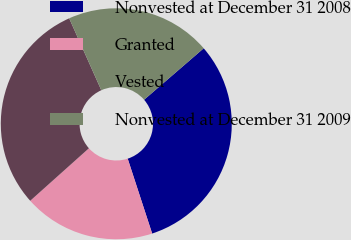Convert chart to OTSL. <chart><loc_0><loc_0><loc_500><loc_500><pie_chart><fcel>Nonvested at December 31 2008<fcel>Granted<fcel>Vested<fcel>Nonvested at December 31 2009<nl><fcel>31.31%<fcel>18.41%<fcel>29.93%<fcel>20.35%<nl></chart> 